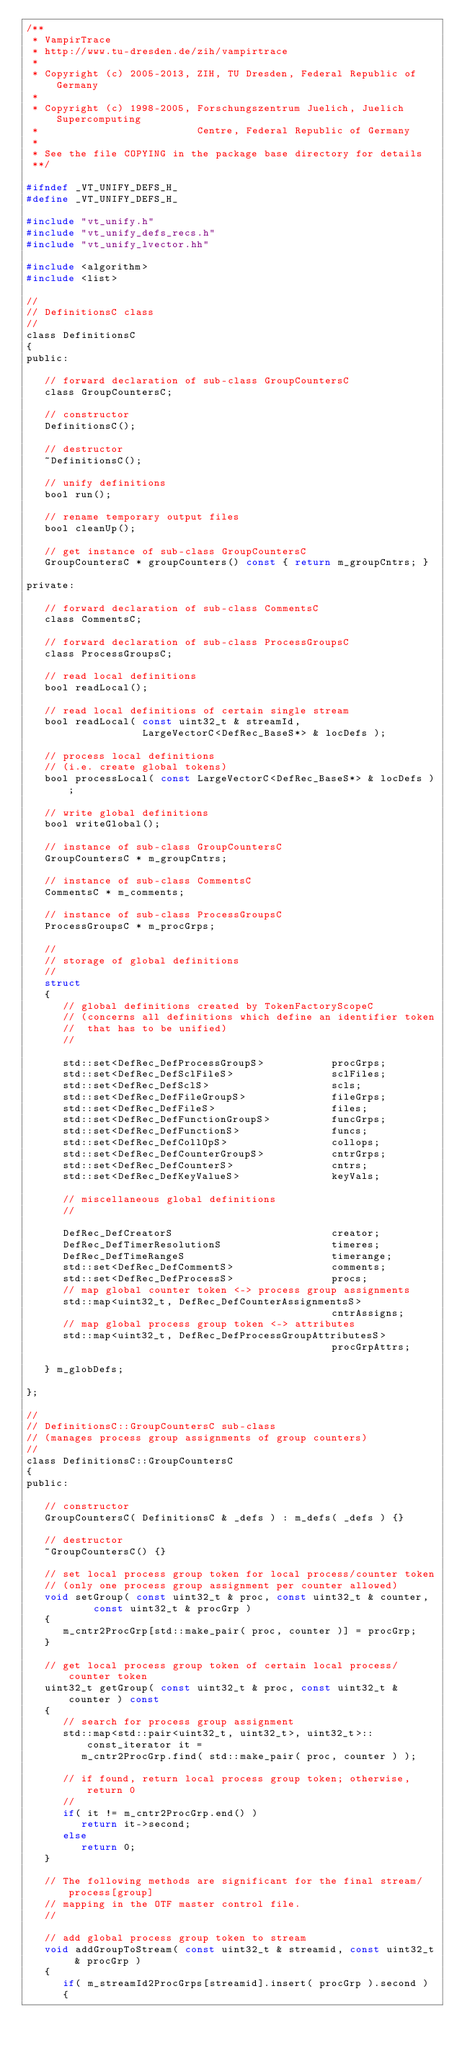<code> <loc_0><loc_0><loc_500><loc_500><_C_>/**
 * VampirTrace
 * http://www.tu-dresden.de/zih/vampirtrace
 *
 * Copyright (c) 2005-2013, ZIH, TU Dresden, Federal Republic of Germany
 *
 * Copyright (c) 1998-2005, Forschungszentrum Juelich, Juelich Supercomputing
 *                          Centre, Federal Republic of Germany
 *
 * See the file COPYING in the package base directory for details
 **/

#ifndef _VT_UNIFY_DEFS_H_
#define _VT_UNIFY_DEFS_H_

#include "vt_unify.h"
#include "vt_unify_defs_recs.h"
#include "vt_unify_lvector.hh"

#include <algorithm>
#include <list>

//
// DefinitionsC class
//
class DefinitionsC
{
public:

   // forward declaration of sub-class GroupCountersC
   class GroupCountersC;

   // constructor
   DefinitionsC();

   // destructor
   ~DefinitionsC();

   // unify definitions
   bool run();

   // rename temporary output files
   bool cleanUp();

   // get instance of sub-class GroupCountersC
   GroupCountersC * groupCounters() const { return m_groupCntrs; }

private:

   // forward declaration of sub-class CommentsC
   class CommentsC;

   // forward declaration of sub-class ProcessGroupsC
   class ProcessGroupsC;

   // read local definitions
   bool readLocal();

   // read local definitions of certain single stream
   bool readLocal( const uint32_t & streamId,
                   LargeVectorC<DefRec_BaseS*> & locDefs );

   // process local definitions
   // (i.e. create global tokens)
   bool processLocal( const LargeVectorC<DefRec_BaseS*> & locDefs );

   // write global definitions
   bool writeGlobal();

   // instance of sub-class GroupCountersC
   GroupCountersC * m_groupCntrs;

   // instance of sub-class CommentsC
   CommentsC * m_comments;

   // instance of sub-class ProcessGroupsC
   ProcessGroupsC * m_procGrps;

   //
   // storage of global definitions
   //
   struct
   {
      // global definitions created by TokenFactoryScopeC
      // (concerns all definitions which define an identifier token
      //  that has to be unified)
      //

      std::set<DefRec_DefProcessGroupS>           procGrps;
      std::set<DefRec_DefSclFileS>                sclFiles;
      std::set<DefRec_DefSclS>                    scls;
      std::set<DefRec_DefFileGroupS>              fileGrps;
      std::set<DefRec_DefFileS>                   files;
      std::set<DefRec_DefFunctionGroupS>          funcGrps;
      std::set<DefRec_DefFunctionS>               funcs;
      std::set<DefRec_DefCollOpS>                 collops;
      std::set<DefRec_DefCounterGroupS>           cntrGrps;
      std::set<DefRec_DefCounterS>                cntrs;
      std::set<DefRec_DefKeyValueS>               keyVals;

      // miscellaneous global definitions
      //

      DefRec_DefCreatorS                          creator;
      DefRec_DefTimerResolutionS                  timeres;
      DefRec_DefTimeRangeS                        timerange;
      std::set<DefRec_DefCommentS>                comments;
      std::set<DefRec_DefProcessS>                procs;
      // map global counter token <-> process group assignments
      std::map<uint32_t, DefRec_DefCounterAssignmentsS>
                                                  cntrAssigns;
      // map global process group token <-> attributes
      std::map<uint32_t, DefRec_DefProcessGroupAttributesS>
                                                  procGrpAttrs;

   } m_globDefs;

};

//
// DefinitionsC::GroupCountersC sub-class
// (manages process group assignments of group counters)
//
class DefinitionsC::GroupCountersC
{
public:

   // constructor
   GroupCountersC( DefinitionsC & _defs ) : m_defs( _defs ) {}

   // destructor
   ~GroupCountersC() {}

   // set local process group token for local process/counter token
   // (only one process group assignment per counter allowed)
   void setGroup( const uint32_t & proc, const uint32_t & counter,
           const uint32_t & procGrp )
   {
      m_cntr2ProcGrp[std::make_pair( proc, counter )] = procGrp;
   }

   // get local process group token of certain local process/counter token
   uint32_t getGroup( const uint32_t & proc, const uint32_t & counter ) const
   {
      // search for process group assignment
      std::map<std::pair<uint32_t, uint32_t>, uint32_t>::const_iterator it =
         m_cntr2ProcGrp.find( std::make_pair( proc, counter ) );

      // if found, return local process group token; otherwise, return 0
      //
      if( it != m_cntr2ProcGrp.end() )
         return it->second;
      else
         return 0;
   }

   // The following methods are significant for the final stream/process[group]
   // mapping in the OTF master control file.
   //

   // add global process group token to stream
   void addGroupToStream( const uint32_t & streamid, const uint32_t & procGrp )
   {
      if( m_streamId2ProcGrps[streamid].insert( procGrp ).second )
      {</code> 